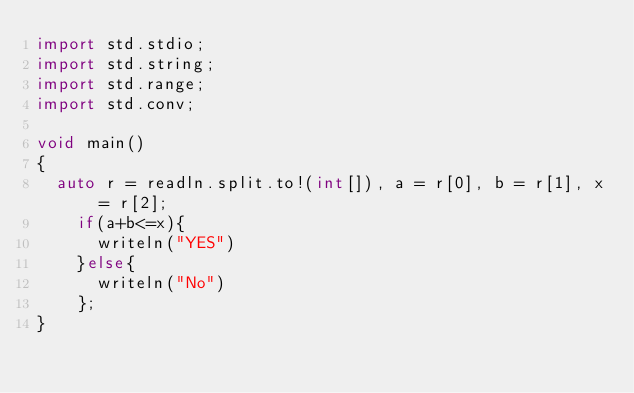<code> <loc_0><loc_0><loc_500><loc_500><_D_>import std.stdio;
import std.string;
import std.range;
import std.conv;

void main()
{
	auto r = readln.split.to!(int[]), a = r[0], b = r[1], x = r[2];
    if(a+b<=x){
    	writeln("YES")
    }else{
    	writeln("No")
    };
}</code> 